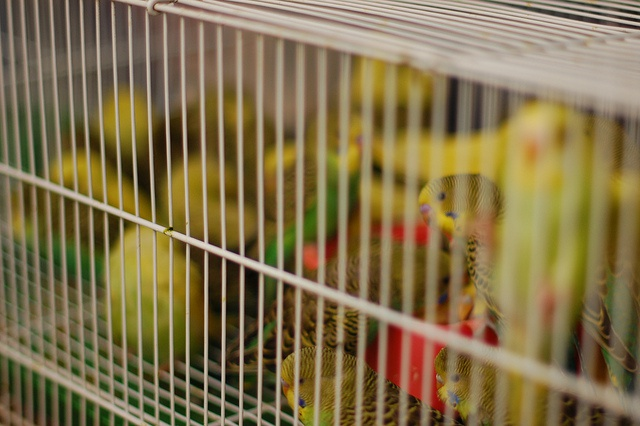Describe the objects in this image and their specific colors. I can see bird in black and olive tones, bird in black, olive, tan, maroon, and gray tones, bird in black, tan, and olive tones, bird in black, olive, and tan tones, and bird in black, olive, tan, maroon, and gray tones in this image. 